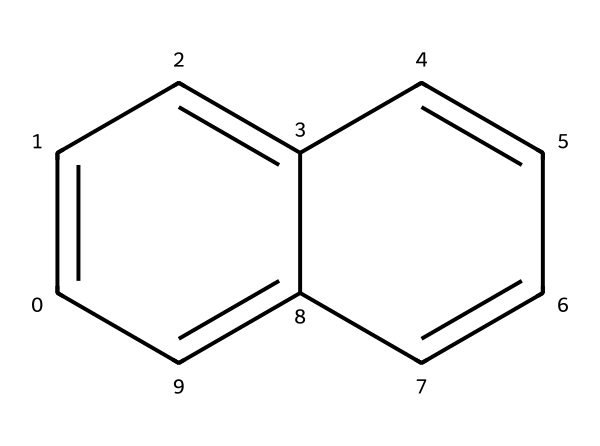What is the name of the chemical represented by this structure? The provided SMILES notation corresponds to naphthalene, which consists of two fused benzene rings. Recognizing the structure allows us to identify it as naphthalene.
Answer: naphthalene How many carbon atoms are in naphthalene? By analyzing the structure, we can count the number of carbon atoms. Naphthalene contains ten carbon atoms in its molecular structure.
Answer: ten What is the total number of hydrogen atoms in naphthalene? Each carbon in naphthalene typically bonds with one hydrogen atom, except for those involved in the fusion between benzene rings. Counting reveals that naphthalene has eight hydrogen atoms.
Answer: eight Is naphthalene aromatic? The presence of cyclic and fully conjugated pi electrons in the fused rings indicates that naphthalene follows Huckel's rule, confirming its aromatic nature.
Answer: yes What is the primary use of naphthalene in household products? Naphthalene is commonly used in mothballs, which serve to protect textiles from moth larvae. This usage is well-known among consumers seeking to preserve wool and other fabrics.
Answer: mothballs How many rings does naphthalene have? The molecular structure clearly shows that naphthalene consists of two fused benzene rings, which form its unique configuration.
Answer: two What type of hydrocarbon is naphthalene classified as? Naphthalene is classified as a polycyclic aromatic hydrocarbon (PAH) due to its structure comprising multiple aromatic rings fused together.
Answer: polycyclic aromatic hydrocarbon 